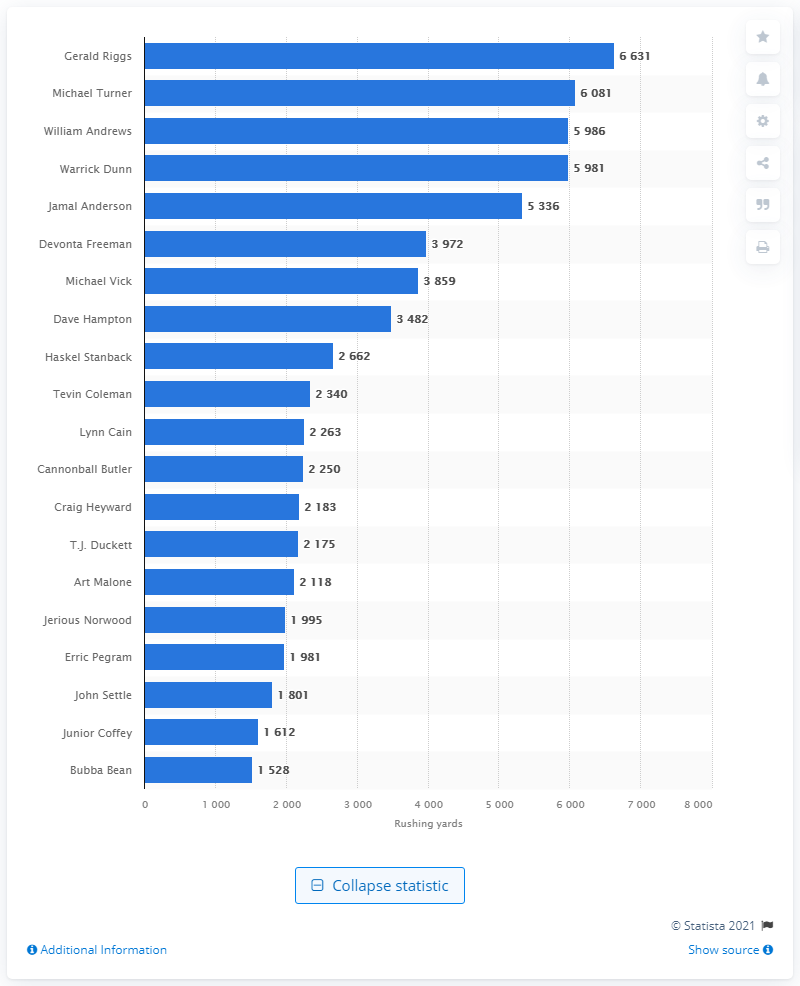Point out several critical features in this image. Gerald Riggs is the career rushing leader of the Atlanta Falcons. 